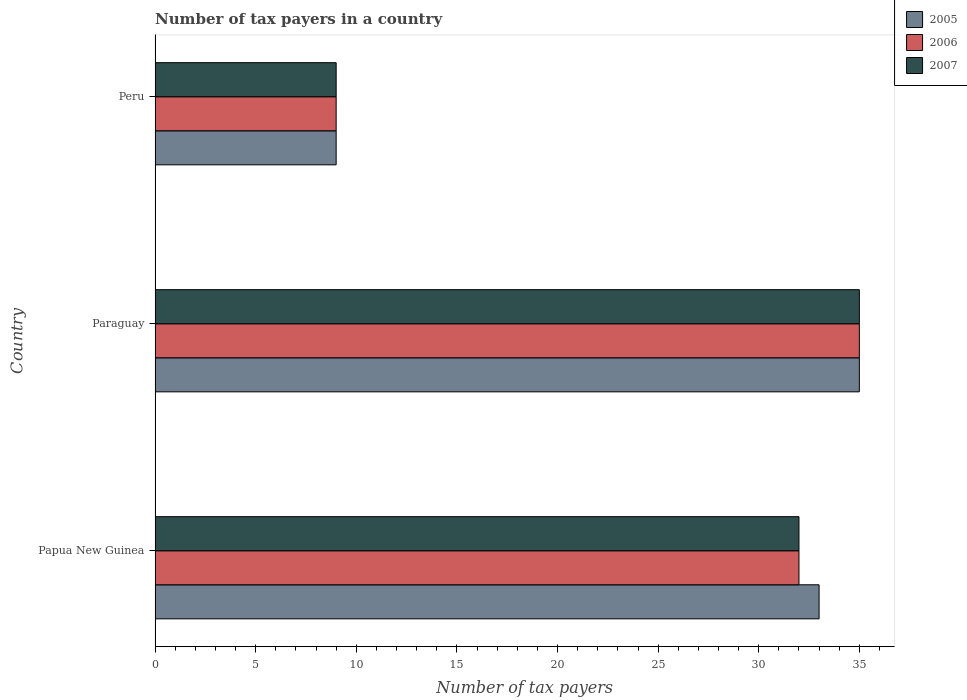Are the number of bars per tick equal to the number of legend labels?
Offer a terse response. Yes. How many bars are there on the 2nd tick from the bottom?
Provide a succinct answer. 3. What is the label of the 2nd group of bars from the top?
Offer a very short reply. Paraguay. Across all countries, what is the maximum number of tax payers in in 2006?
Your answer should be compact. 35. Across all countries, what is the minimum number of tax payers in in 2005?
Provide a succinct answer. 9. In which country was the number of tax payers in in 2006 maximum?
Provide a short and direct response. Paraguay. In which country was the number of tax payers in in 2005 minimum?
Your response must be concise. Peru. What is the difference between the number of tax payers in in 2005 in Papua New Guinea and that in Paraguay?
Provide a short and direct response. -2. What is the average number of tax payers in in 2005 per country?
Your answer should be compact. 25.67. What is the difference between the number of tax payers in in 2006 and number of tax payers in in 2007 in Papua New Guinea?
Provide a short and direct response. 0. In how many countries, is the number of tax payers in in 2006 greater than 5 ?
Offer a terse response. 3. What is the ratio of the number of tax payers in in 2005 in Papua New Guinea to that in Peru?
Offer a terse response. 3.67. What is the difference between the highest and the second highest number of tax payers in in 2006?
Your response must be concise. 3. In how many countries, is the number of tax payers in in 2006 greater than the average number of tax payers in in 2006 taken over all countries?
Ensure brevity in your answer.  2. Are all the bars in the graph horizontal?
Provide a short and direct response. Yes. How many countries are there in the graph?
Provide a short and direct response. 3. What is the difference between two consecutive major ticks on the X-axis?
Your answer should be compact. 5. Are the values on the major ticks of X-axis written in scientific E-notation?
Provide a succinct answer. No. Does the graph contain any zero values?
Your response must be concise. No. Where does the legend appear in the graph?
Your answer should be compact. Top right. How are the legend labels stacked?
Keep it short and to the point. Vertical. What is the title of the graph?
Provide a short and direct response. Number of tax payers in a country. Does "1970" appear as one of the legend labels in the graph?
Provide a succinct answer. No. What is the label or title of the X-axis?
Your answer should be very brief. Number of tax payers. What is the label or title of the Y-axis?
Your answer should be compact. Country. What is the Number of tax payers of 2007 in Paraguay?
Offer a terse response. 35. What is the Number of tax payers of 2005 in Peru?
Provide a succinct answer. 9. Across all countries, what is the maximum Number of tax payers of 2005?
Make the answer very short. 35. Across all countries, what is the maximum Number of tax payers in 2006?
Give a very brief answer. 35. Across all countries, what is the maximum Number of tax payers of 2007?
Keep it short and to the point. 35. Across all countries, what is the minimum Number of tax payers in 2006?
Offer a terse response. 9. Across all countries, what is the minimum Number of tax payers in 2007?
Your answer should be very brief. 9. What is the total Number of tax payers of 2007 in the graph?
Your response must be concise. 76. What is the difference between the Number of tax payers of 2005 in Papua New Guinea and that in Paraguay?
Your answer should be compact. -2. What is the difference between the Number of tax payers of 2006 in Papua New Guinea and that in Paraguay?
Keep it short and to the point. -3. What is the difference between the Number of tax payers in 2007 in Papua New Guinea and that in Paraguay?
Your answer should be very brief. -3. What is the difference between the Number of tax payers of 2006 in Papua New Guinea and that in Peru?
Make the answer very short. 23. What is the difference between the Number of tax payers in 2005 in Papua New Guinea and the Number of tax payers in 2006 in Peru?
Provide a short and direct response. 24. What is the difference between the Number of tax payers in 2005 in Papua New Guinea and the Number of tax payers in 2007 in Peru?
Make the answer very short. 24. What is the difference between the Number of tax payers of 2006 in Paraguay and the Number of tax payers of 2007 in Peru?
Provide a succinct answer. 26. What is the average Number of tax payers in 2005 per country?
Your answer should be compact. 25.67. What is the average Number of tax payers in 2006 per country?
Ensure brevity in your answer.  25.33. What is the average Number of tax payers in 2007 per country?
Your response must be concise. 25.33. What is the difference between the Number of tax payers of 2005 and Number of tax payers of 2006 in Papua New Guinea?
Offer a very short reply. 1. What is the difference between the Number of tax payers of 2006 and Number of tax payers of 2007 in Papua New Guinea?
Offer a terse response. 0. What is the difference between the Number of tax payers in 2005 and Number of tax payers in 2007 in Paraguay?
Provide a short and direct response. 0. What is the difference between the Number of tax payers in 2005 and Number of tax payers in 2006 in Peru?
Offer a very short reply. 0. What is the ratio of the Number of tax payers of 2005 in Papua New Guinea to that in Paraguay?
Provide a succinct answer. 0.94. What is the ratio of the Number of tax payers of 2006 in Papua New Guinea to that in Paraguay?
Make the answer very short. 0.91. What is the ratio of the Number of tax payers of 2007 in Papua New Guinea to that in Paraguay?
Your answer should be compact. 0.91. What is the ratio of the Number of tax payers of 2005 in Papua New Guinea to that in Peru?
Your answer should be compact. 3.67. What is the ratio of the Number of tax payers in 2006 in Papua New Guinea to that in Peru?
Keep it short and to the point. 3.56. What is the ratio of the Number of tax payers of 2007 in Papua New Guinea to that in Peru?
Ensure brevity in your answer.  3.56. What is the ratio of the Number of tax payers of 2005 in Paraguay to that in Peru?
Ensure brevity in your answer.  3.89. What is the ratio of the Number of tax payers in 2006 in Paraguay to that in Peru?
Make the answer very short. 3.89. What is the ratio of the Number of tax payers of 2007 in Paraguay to that in Peru?
Your response must be concise. 3.89. What is the difference between the highest and the second highest Number of tax payers in 2006?
Make the answer very short. 3. What is the difference between the highest and the second highest Number of tax payers in 2007?
Your answer should be compact. 3. What is the difference between the highest and the lowest Number of tax payers of 2005?
Provide a short and direct response. 26. 